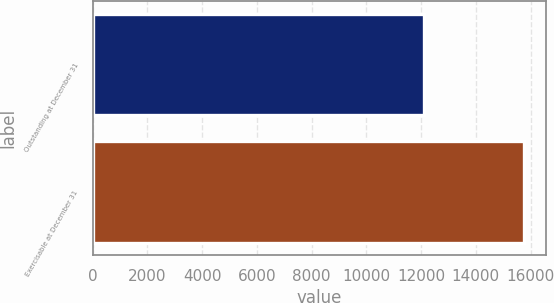Convert chart. <chart><loc_0><loc_0><loc_500><loc_500><bar_chart><fcel>Outstanding at December 31<fcel>Exercisable at December 31<nl><fcel>12121<fcel>15773<nl></chart> 